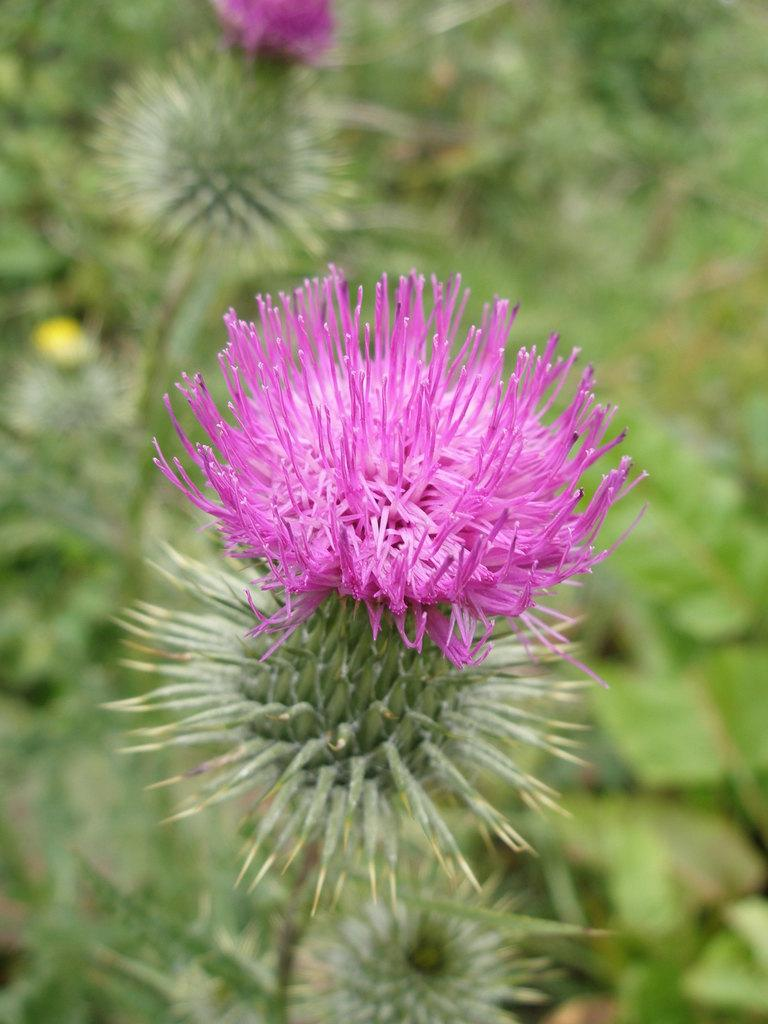What can be observed about the background of the image? The background portion of the picture is blurred. What type of plants are present in the image? There are flowers and green leaves in the image. What role does the actor play in the image? There is no actor present in the image; it features flowers and green leaves. How comfortable is the seating arrangement in the image? There is no seating arrangement present in the image, as it focuses on plants. 